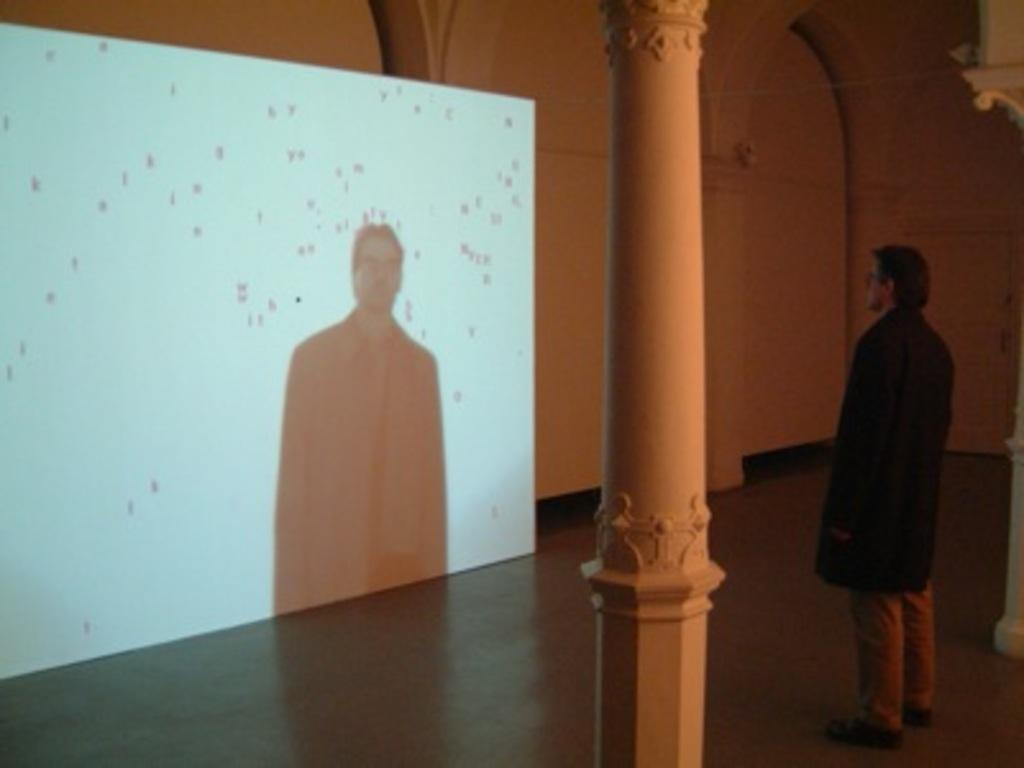What is being displayed in the image? There is a projector display in the image. Can you describe the person in the image? A man is standing on the floor in the image. What type of architectural features can be seen in the image? There are walls and pillars visible in the image. What kind of electrical device is present in the image? An electric notch is present in the image. How many yaks are resting on the beds in the image? There are no yaks or beds present in the image. What type of knowledge is being shared in the image? The image does not depict any knowledge being shared; it only shows a projector display, a man, walls, pillars, and an electric notch. 